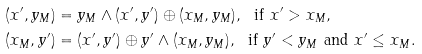<formula> <loc_0><loc_0><loc_500><loc_500>& ( x ^ { \prime } , y _ { M } ) = y _ { M } \wedge ( x ^ { \prime } , y ^ { \prime } ) \oplus ( x _ { M } , y _ { M } ) , \ \text { if } x ^ { \prime } > x _ { M } , \\ & ( x _ { M } , y ^ { \prime } ) = ( x ^ { \prime } , y ^ { \prime } ) \oplus y ^ { \prime } \wedge ( x _ { M } , y _ { M } ) , \ \text { if } y ^ { \prime } < y _ { M } \text { and } x ^ { \prime } \leq x _ { M } .</formula> 